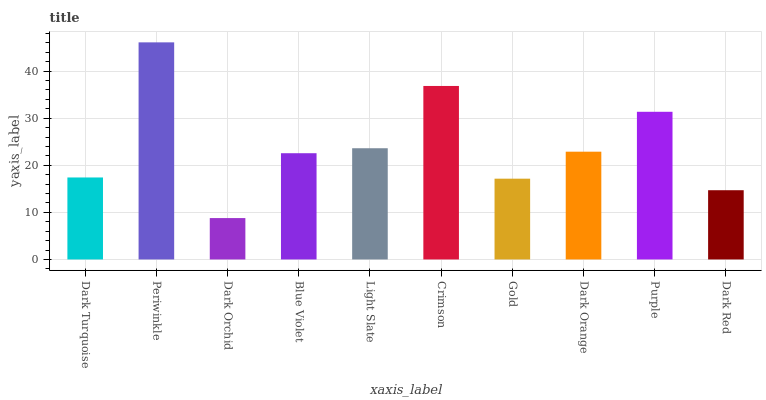Is Dark Orchid the minimum?
Answer yes or no. Yes. Is Periwinkle the maximum?
Answer yes or no. Yes. Is Periwinkle the minimum?
Answer yes or no. No. Is Dark Orchid the maximum?
Answer yes or no. No. Is Periwinkle greater than Dark Orchid?
Answer yes or no. Yes. Is Dark Orchid less than Periwinkle?
Answer yes or no. Yes. Is Dark Orchid greater than Periwinkle?
Answer yes or no. No. Is Periwinkle less than Dark Orchid?
Answer yes or no. No. Is Dark Orange the high median?
Answer yes or no. Yes. Is Blue Violet the low median?
Answer yes or no. Yes. Is Purple the high median?
Answer yes or no. No. Is Purple the low median?
Answer yes or no. No. 